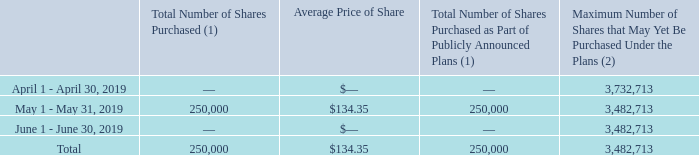Issuer Purchases of Equity Securities
The following shares of the Company were repurchased during the quarter ended June 30, 2019:
(1) 250,000 shares were purchased through a publicly announced repurchase plan. There were no shares surrendered to the Company to satisfy tax withholding obligations in connection with employee restricted stock awards.
(2) Total stock repurchase authorizations approved by the Company’s Board of Directors as of February 17, 2015 were for 30.0 million shares. These authorizations have no specific dollar or share price targets and no expiration dates.
What are the three date periods shown in the table? April 1 - april 30, 2019, may 1 - may 31, 2019, june 1 - june 30, 2019. What are the maximum number of shares that may yet be purchased under the plans as at April 1 - April 30, 2019 and May 1 - May 31, 2019 respectively? 3,732,713, 3,482,713. What is the total number of shares purchased? 250,000. Between April 1 - April 30, 2019 and May 1 - May 31, 2019, which period had a greater amount of maximum number of shares that may yet be purchased under the plans? 3,732,713>3,482,713
Answer: april 1 - april 30, 2019. What was the cost of the shares purchased from May 1 - May 31, 2019? 250,000*$134.35
Answer: 33587500. What percentage of maximum shares that may yet be purchased under the plans as at April 1 - April 30, 2019 is the maximum number of shares that may be purchased as at May 1 - May 31,2019?
Answer scale should be: percent. 3,482,713/3,732,713
Answer: 93.3. 